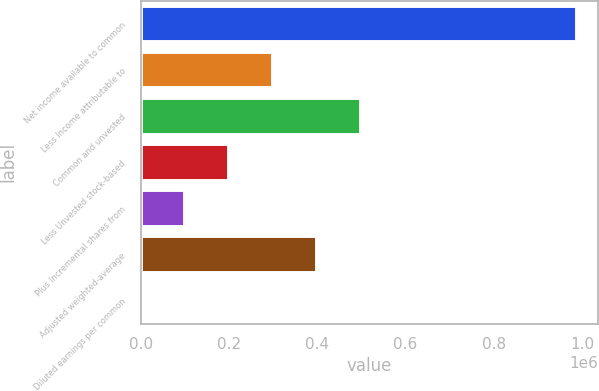Convert chart to OTSL. <chart><loc_0><loc_0><loc_500><loc_500><bar_chart><fcel>Net income available to common<fcel>Less Income attributable to<fcel>Common and unvested<fcel>Less Unvested stock-based<fcel>Plus Incremental shares from<fcel>Adjusted weighted-average<fcel>Diluted earnings per common<nl><fcel>987724<fcel>299524<fcel>499202<fcel>199685<fcel>99846.2<fcel>399363<fcel>7.18<nl></chart> 